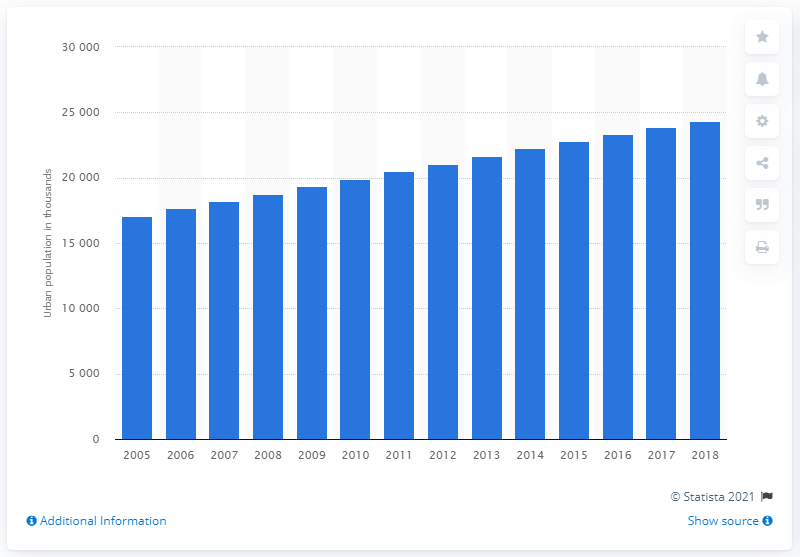Indicate a few pertinent items in this graphic. The urban population in Malaysia began to increase in the year 2005. 